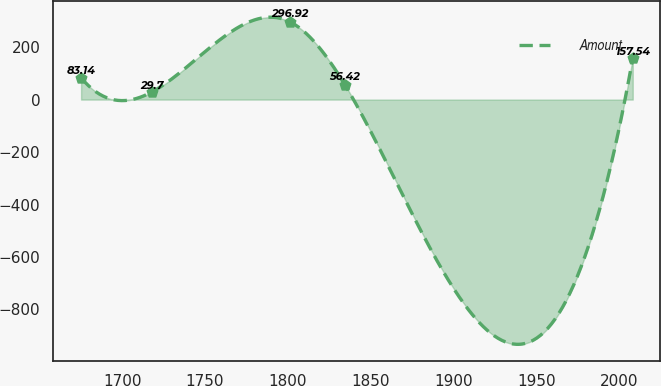Convert chart to OTSL. <chart><loc_0><loc_0><loc_500><loc_500><line_chart><ecel><fcel>Amount<nl><fcel>1675.23<fcel>83.14<nl><fcel>1718.15<fcel>29.7<nl><fcel>1801.14<fcel>296.92<nl><fcel>1834.44<fcel>56.42<nl><fcel>2008.18<fcel>157.54<nl></chart> 